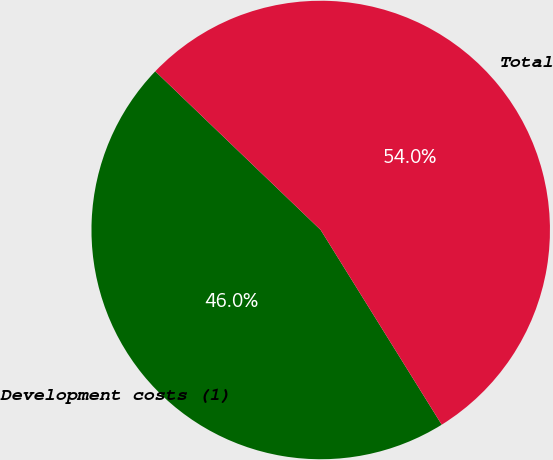Convert chart. <chart><loc_0><loc_0><loc_500><loc_500><pie_chart><fcel>Development costs (1)<fcel>Total<nl><fcel>46.02%<fcel>53.98%<nl></chart> 